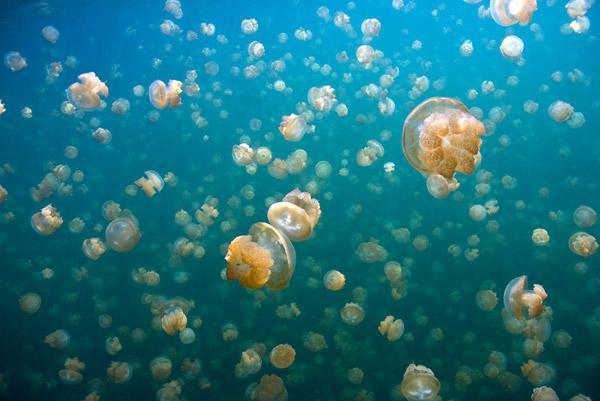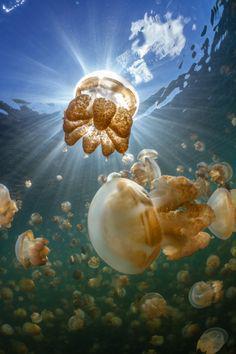The first image is the image on the left, the second image is the image on the right. Analyze the images presented: Is the assertion "Jellyfish are the same color in the right and left images." valid? Answer yes or no. Yes. The first image is the image on the left, the second image is the image on the right. Considering the images on both sides, is "There are at least one hundred light orange jellyfish in the iamge on the left" valid? Answer yes or no. Yes. 